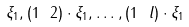<formula> <loc_0><loc_0><loc_500><loc_500>\xi _ { 1 } , ( 1 \ 2 ) \cdot \xi _ { 1 } , \dots , ( 1 \ l ) \cdot \xi _ { 1 }</formula> 